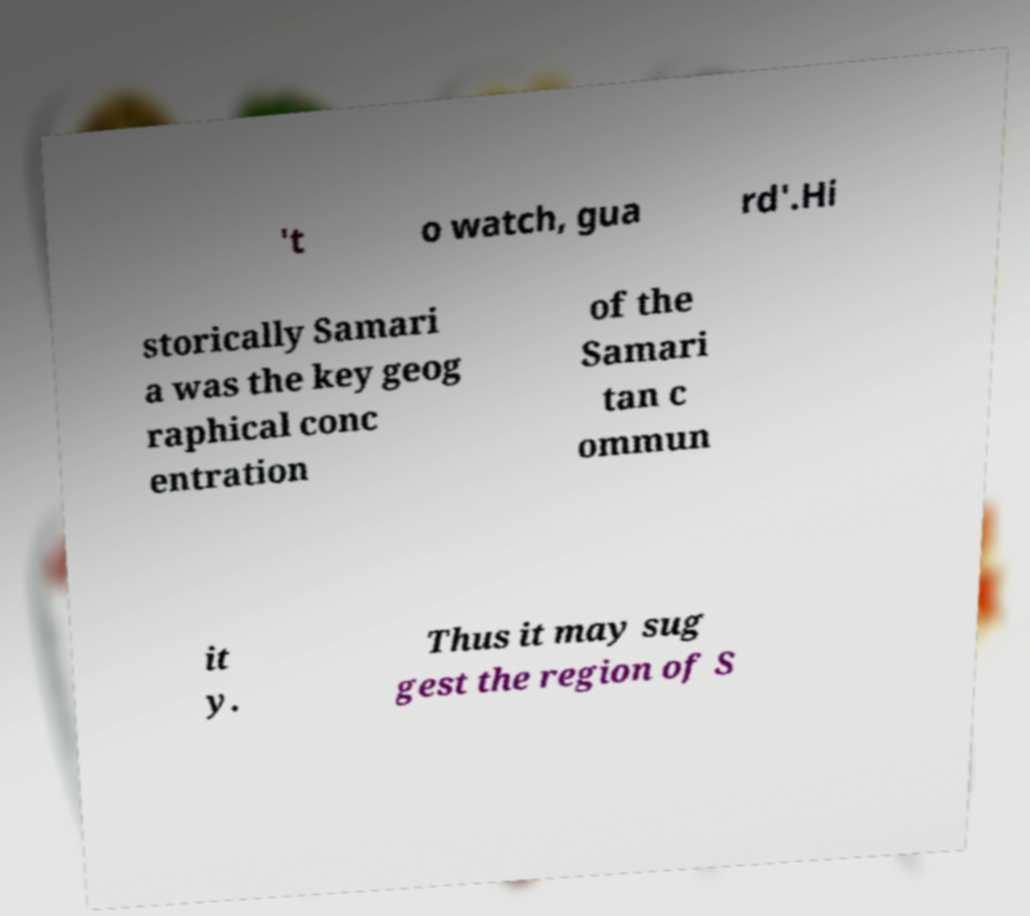There's text embedded in this image that I need extracted. Can you transcribe it verbatim? 't o watch, gua rd'.Hi storically Samari a was the key geog raphical conc entration of the Samari tan c ommun it y. Thus it may sug gest the region of S 